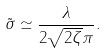Convert formula to latex. <formula><loc_0><loc_0><loc_500><loc_500>\tilde { \sigma } \simeq \frac { \lambda } { 2 \sqrt { 2 \zeta } \pi } .</formula> 